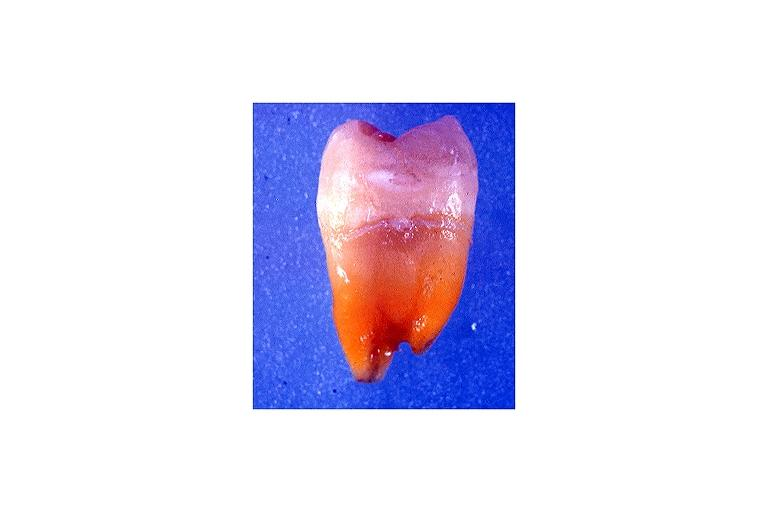s oral present?
Answer the question using a single word or phrase. Yes 